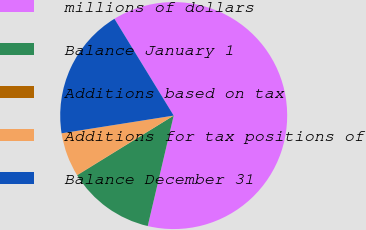Convert chart. <chart><loc_0><loc_0><loc_500><loc_500><pie_chart><fcel>millions of dollars<fcel>Balance January 1<fcel>Additions based on tax<fcel>Additions for tax positions of<fcel>Balance December 31<nl><fcel>62.42%<fcel>12.51%<fcel>0.04%<fcel>6.28%<fcel>18.75%<nl></chart> 